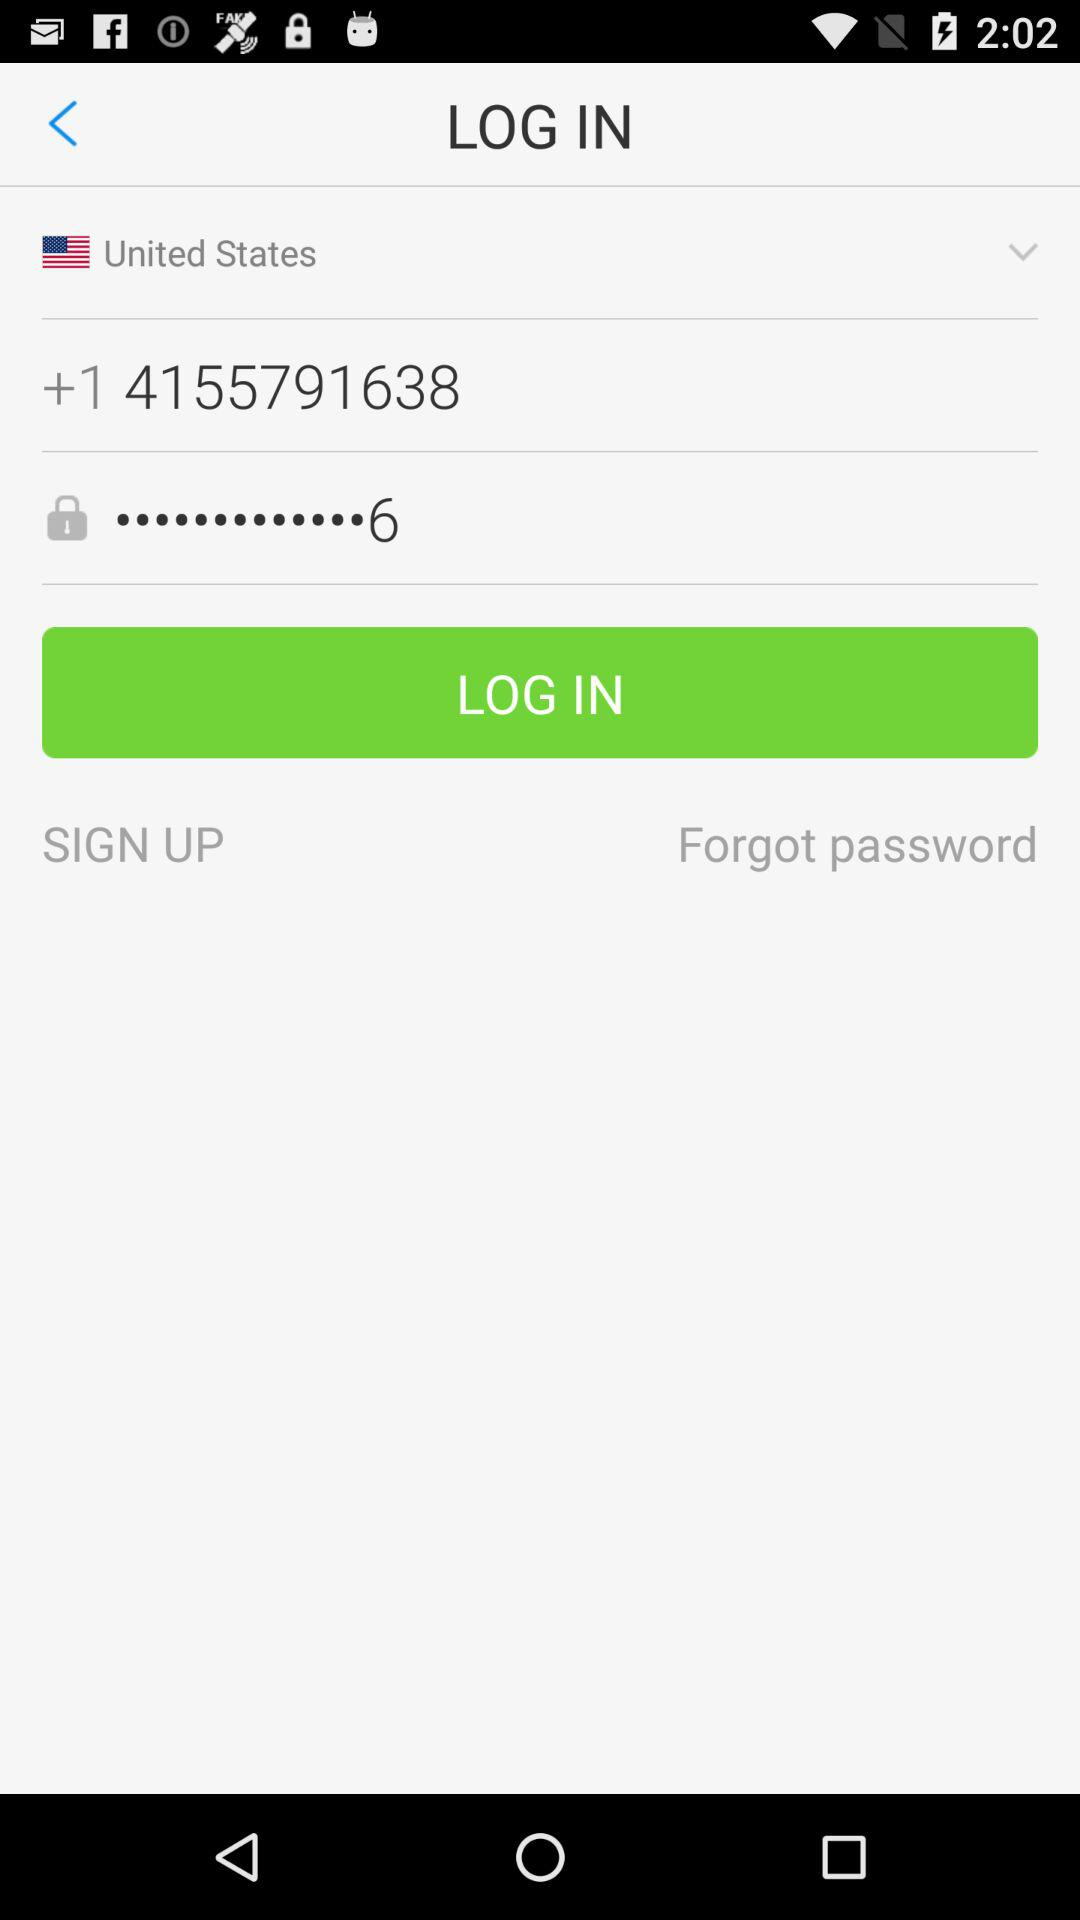What is the selected country? The selected country is the "United States". 